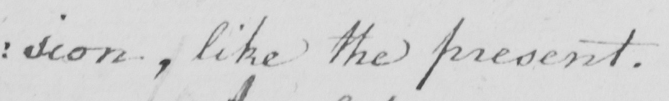Please transcribe the handwritten text in this image. : sion , like the present . 